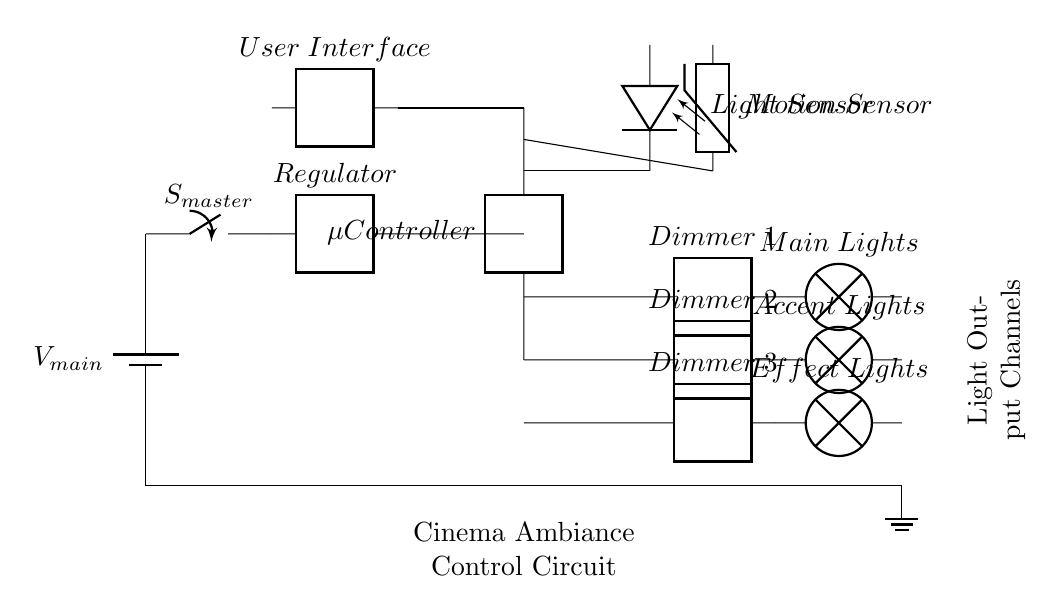What is the main power source for this circuit? The circuit is powered by a battery labeled as "V main", indicating it is the main power supply for the circuit operations.
Answer: V main How many dimmer circuits are present in the diagram? The diagram shows three dimmers, which are marked as Dimmer 1, Dimmer 2, and Dimmer 3 with their respective connections to different lighting types.
Answer: 3 What is the function of the light sensor in this circuit? The light sensor, marked as "Light Sensor," is used to detect ambient light levels and can signal the microcontroller to adjust the lighting conditions accordingly.
Answer: Adjust lighting Which component regulates the voltage in the circuit? The voltage regulator in the circuit is specifically labeled as "Regulator," highlighting its role in maintaining a stable voltage level for the operation of connected devices.
Answer: Regulator How many types of lights are controlled by this circuit? The circuit controls three types of lights: Main Lights, Accent Lights, and Effect Lights, as indicated by the labels next to each dimmer circuit.
Answer: 3 types What does the user interface connect to in this circuit? The user interface connects to the microcontroller, allowing users to interact with and control the operation of the overall circuit and lighting ambiance.
Answer: Microcontroller 